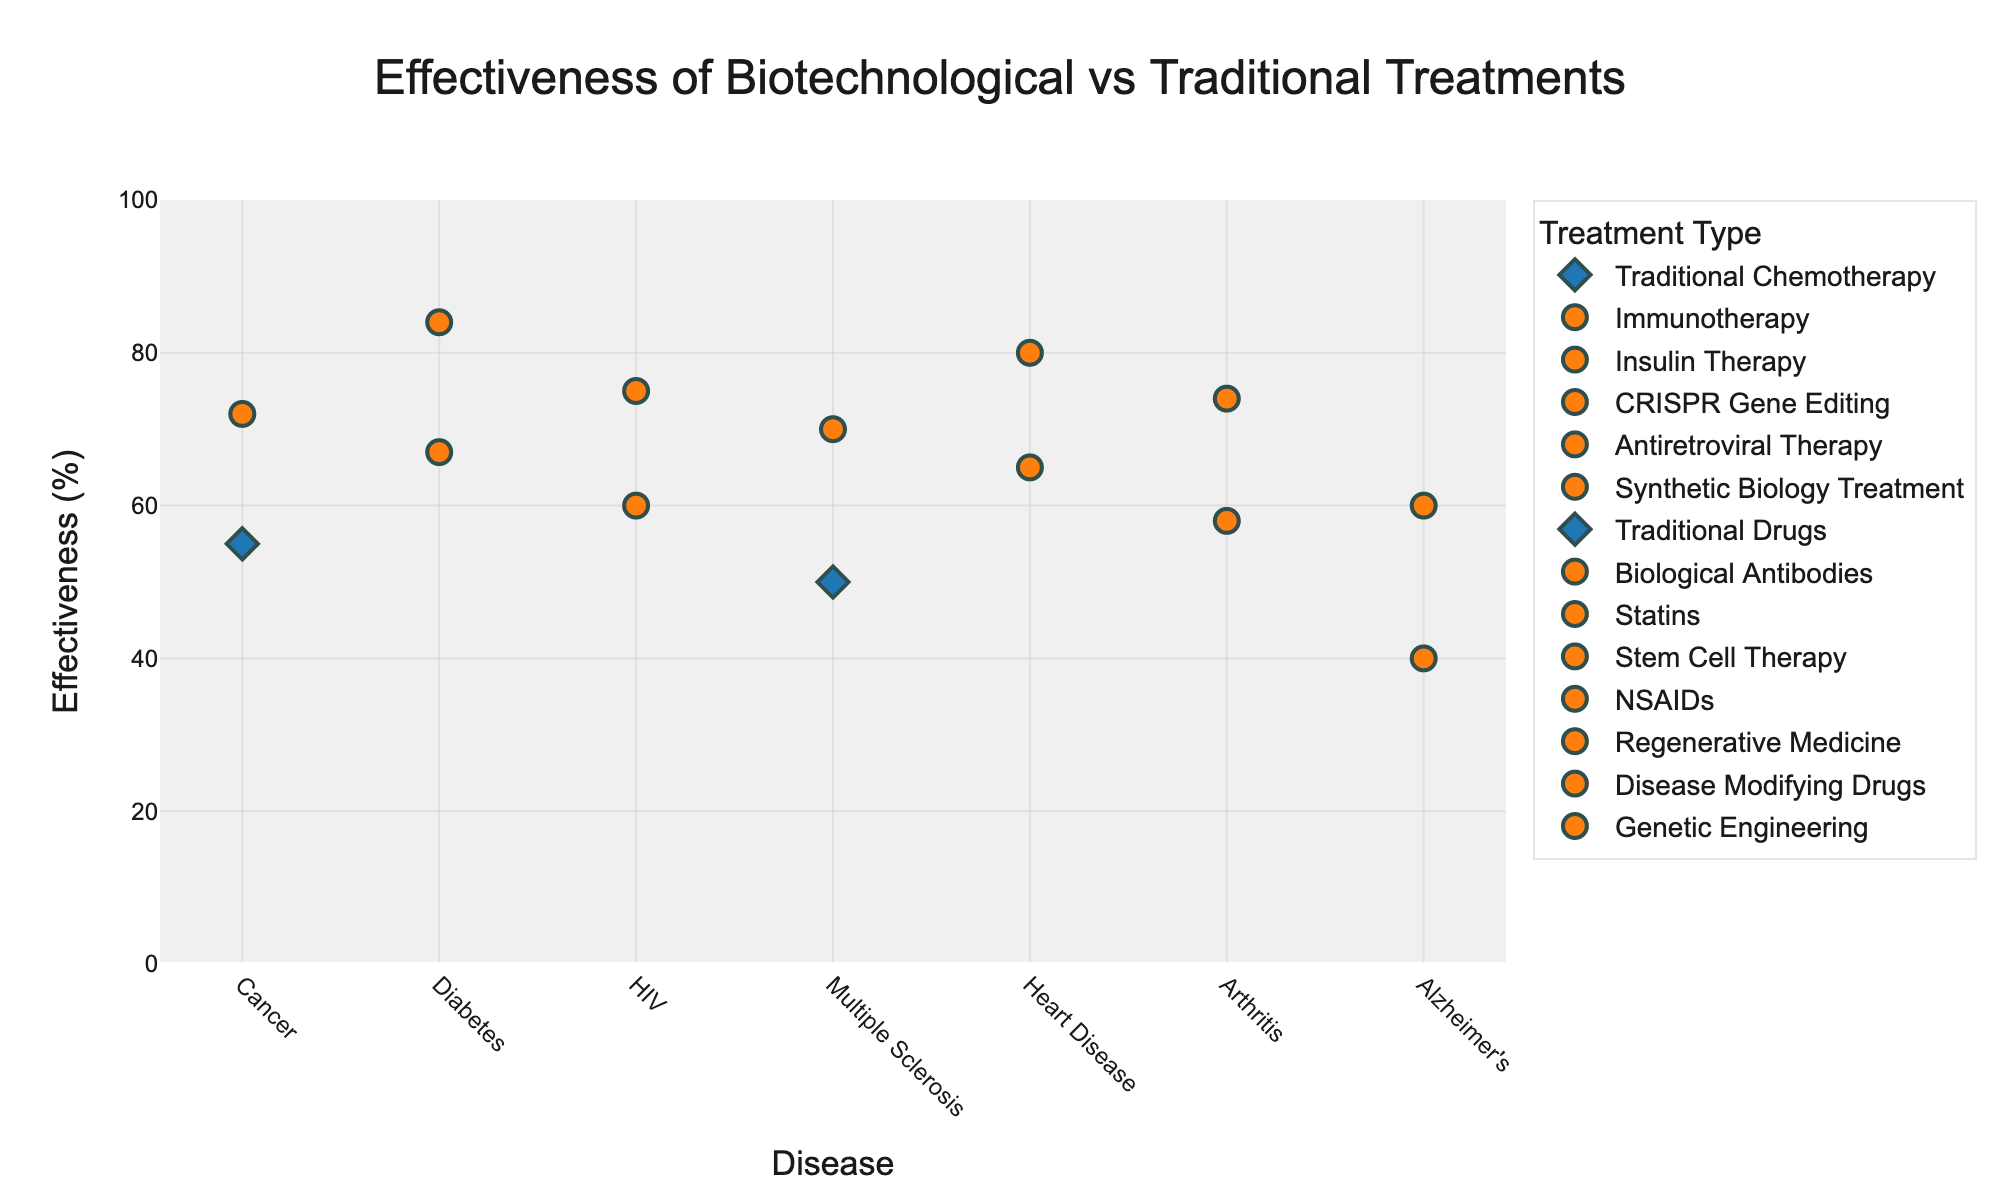What is the title of the figure? The title of the figure is usually located at the top center in larger font size and different color from other text in the plot. In this plot, the title reads "Effectiveness of Biotechnological vs Traditional Treatments".
Answer: Effectiveness of Biotechnological vs Traditional Treatments What is the y-axis representing? The y-axis usually has a label that indicates what it is representing in the plot. In this case, the y-axis is labeled "Effectiveness (%)", indicating it represents the effectiveness percentage of each treatment.
Answer: Effectiveness (%) How many diseases are displayed in the figure? To determine the number of distinct diseases, observe the x-axis's tick labels. The figure shows labels for the following diseases: Cancer, Diabetes, HIV, Multiple Sclerosis, Heart Disease, Arthritis, and Alzheimer's, making a total of 7 diseases.
Answer: 7 Which treatment type has a symbol of a diamond? Treatments that contain the word "Traditional" in their name are marked with a diamond symbol. These can be identified by looking at the marker shapes in the legend and on the plot.
Answer: Traditional treatments What is the difference in effectiveness between Traditional Chemotherapy and Immunotherapy for Cancer? Observe the effectiveness values on the y-axis for both treatments. Traditional Chemotherapy has an effectiveness of 55, while Immunotherapy is at 72. The difference is calculated as 72 - 55.
Answer: 17 Which treatment for Diabetes shows higher effectiveness? To compare treatments for Diabetes, observe the y-axis values. Insulin Therapy shows an effectiveness of 67, while CRISPR Gene Editing shows an effectiveness of 84. The higher value indicates greater effectiveness.
Answer: CRISPR Gene Editing How does the effectiveness of Biological Antibodies for Multiple Sclerosis compare to Traditional Drugs? Compare the y-axis values for both treatments. Traditional Drugs have an effectiveness of 50, while Biological Antibodies have an effectiveness of 70. Biological Antibodies are more effective.
Answer: Biological Antibodies are more effective What is the average effectiveness of the biotechnological treatments given in the figure? Identify biotechnological treatments: Immunotherapy (72), CRISPR Gene Editing (84), Synthetic Biology Treatment (75), Biological Antibodies (70), Stem Cell Therapy (80), Regenerative Medicine (74), and Genetic Engineering (60). Sum these values (72+84+75+70+80+74+60) = 515 and divide by 7.
Answer: 73.57 Which disease has the lowest effectivenes treatment? Compare the effectiveness values for each disease on the y-axis. Alzheimer's Disease Modifying Drugs has an effectiveness of 40, which is the lowest among all treatments.
Answer: Alzheimer's Disease (Traditional) How many novel biotechnological treatments have an effectiveness of 70% or higher? Identify effectiveness values for novel biotechnological treatments and count those with values 70 or higher: Immunotherapy (72), CRISPR Gene Editing (84), Synthetic Biology Treatment (75), Biological Antibodies (70), Stem Cell Therapy (80), Regenerative Medicine (74). This counts to 6.
Answer: 6 